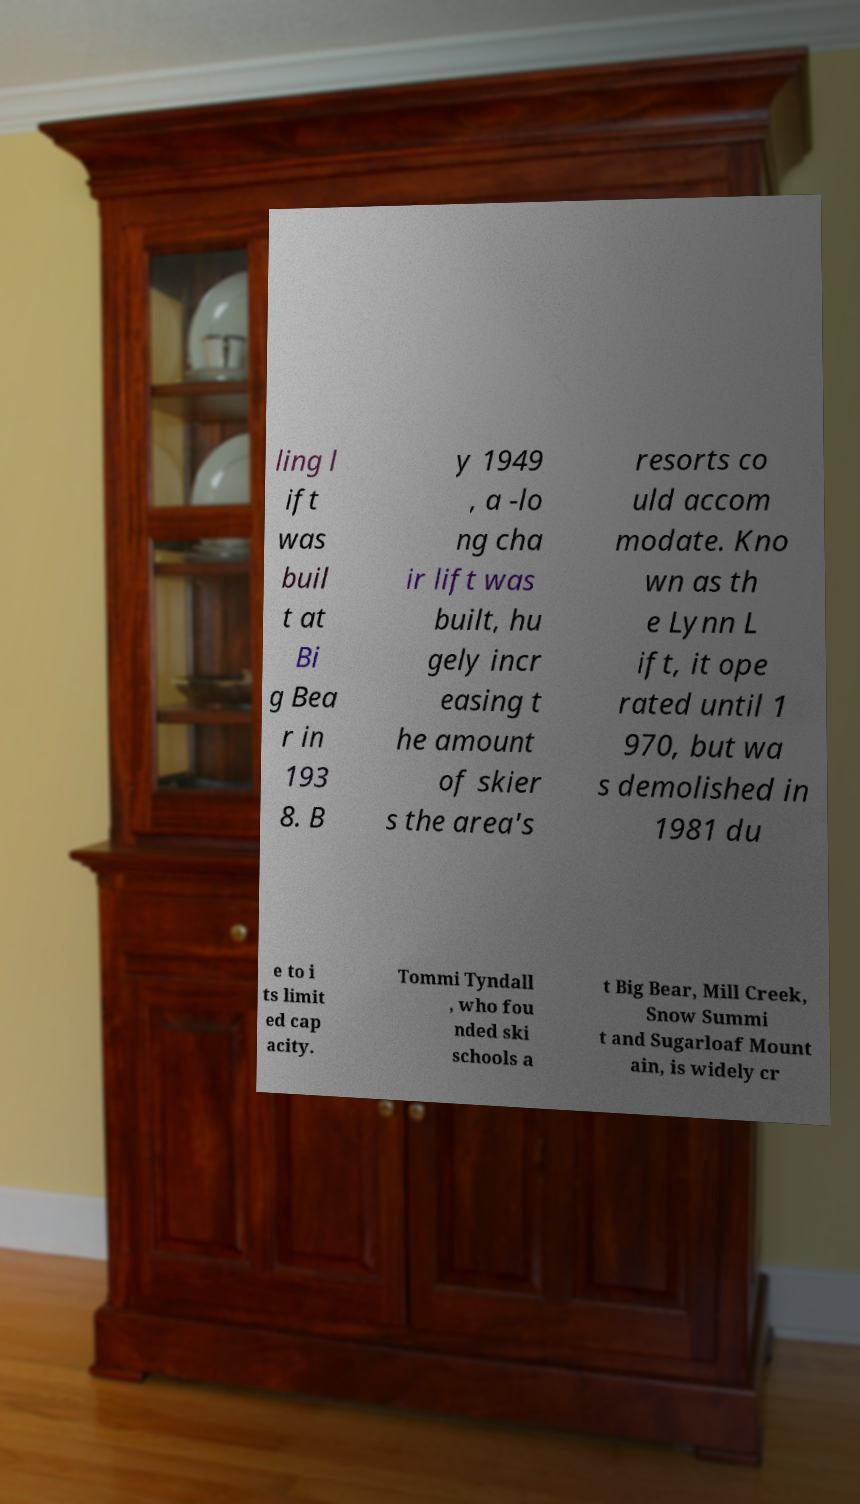Please identify and transcribe the text found in this image. ling l ift was buil t at Bi g Bea r in 193 8. B y 1949 , a -lo ng cha ir lift was built, hu gely incr easing t he amount of skier s the area's resorts co uld accom modate. Kno wn as th e Lynn L ift, it ope rated until 1 970, but wa s demolished in 1981 du e to i ts limit ed cap acity. Tommi Tyndall , who fou nded ski schools a t Big Bear, Mill Creek, Snow Summi t and Sugarloaf Mount ain, is widely cr 